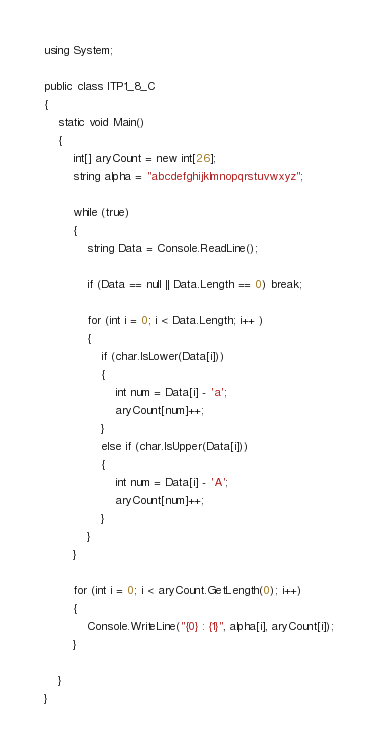Convert code to text. <code><loc_0><loc_0><loc_500><loc_500><_C#_>using System;

public class ITP1_8_C
{
    static void Main()
    {
        int[] aryCount = new int[26];
        string alpha = "abcdefghijklmnopqrstuvwxyz";

        while (true)
        {
            string Data = Console.ReadLine();

            if (Data == null || Data.Length == 0) break;

            for (int i = 0; i < Data.Length; i++ )
            {
                if (char.IsLower(Data[i]))
                {
                    int num = Data[i] - 'a';
                    aryCount[num]++;
                }
                else if (char.IsUpper(Data[i]))
                {
                    int num = Data[i] - 'A';
                    aryCount[num]++;
                }
            }
        }

        for (int i = 0; i < aryCount.GetLength(0); i++)
        {
            Console.WriteLine("{0} : {1}", alpha[i], aryCount[i]);
        }

    }
}</code> 